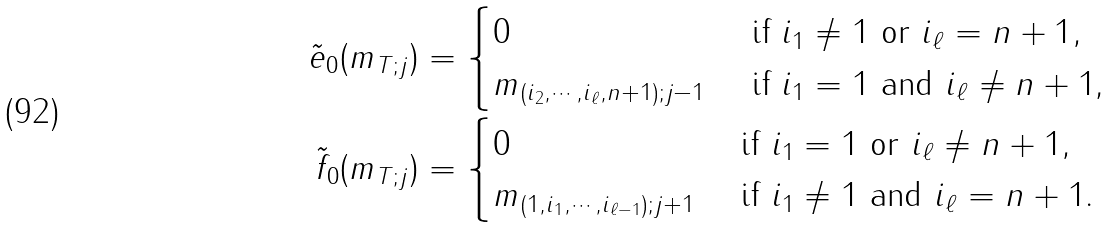Convert formula to latex. <formula><loc_0><loc_0><loc_500><loc_500>\tilde { e } _ { 0 } ( m _ { T ; j } ) & = \begin{cases} 0 & \text { if $i_{1}\neq 1$ or $i_{\ell}=n+1$} , \\ m _ { ( i _ { 2 } , \cdots , i _ { \ell } , n + 1 ) ; j - 1 } & \text { if $i_{1}=1$ and $i_{\ell}\neq n+1$,} \end{cases} \\ \tilde { f } _ { 0 } ( m _ { T ; j } ) & = \begin{cases} 0 & \text { if $i_{1} = 1$ or $i_{\ell} \neq n+1$} , \\ m _ { ( 1 , i _ { 1 } , \cdots , i _ { \ell - 1 } ) ; j + 1 } & \text { if $i_{1} \neq 1$ and $i_{\ell} = n+1$.} \end{cases}</formula> 